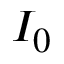Convert formula to latex. <formula><loc_0><loc_0><loc_500><loc_500>I _ { 0 }</formula> 